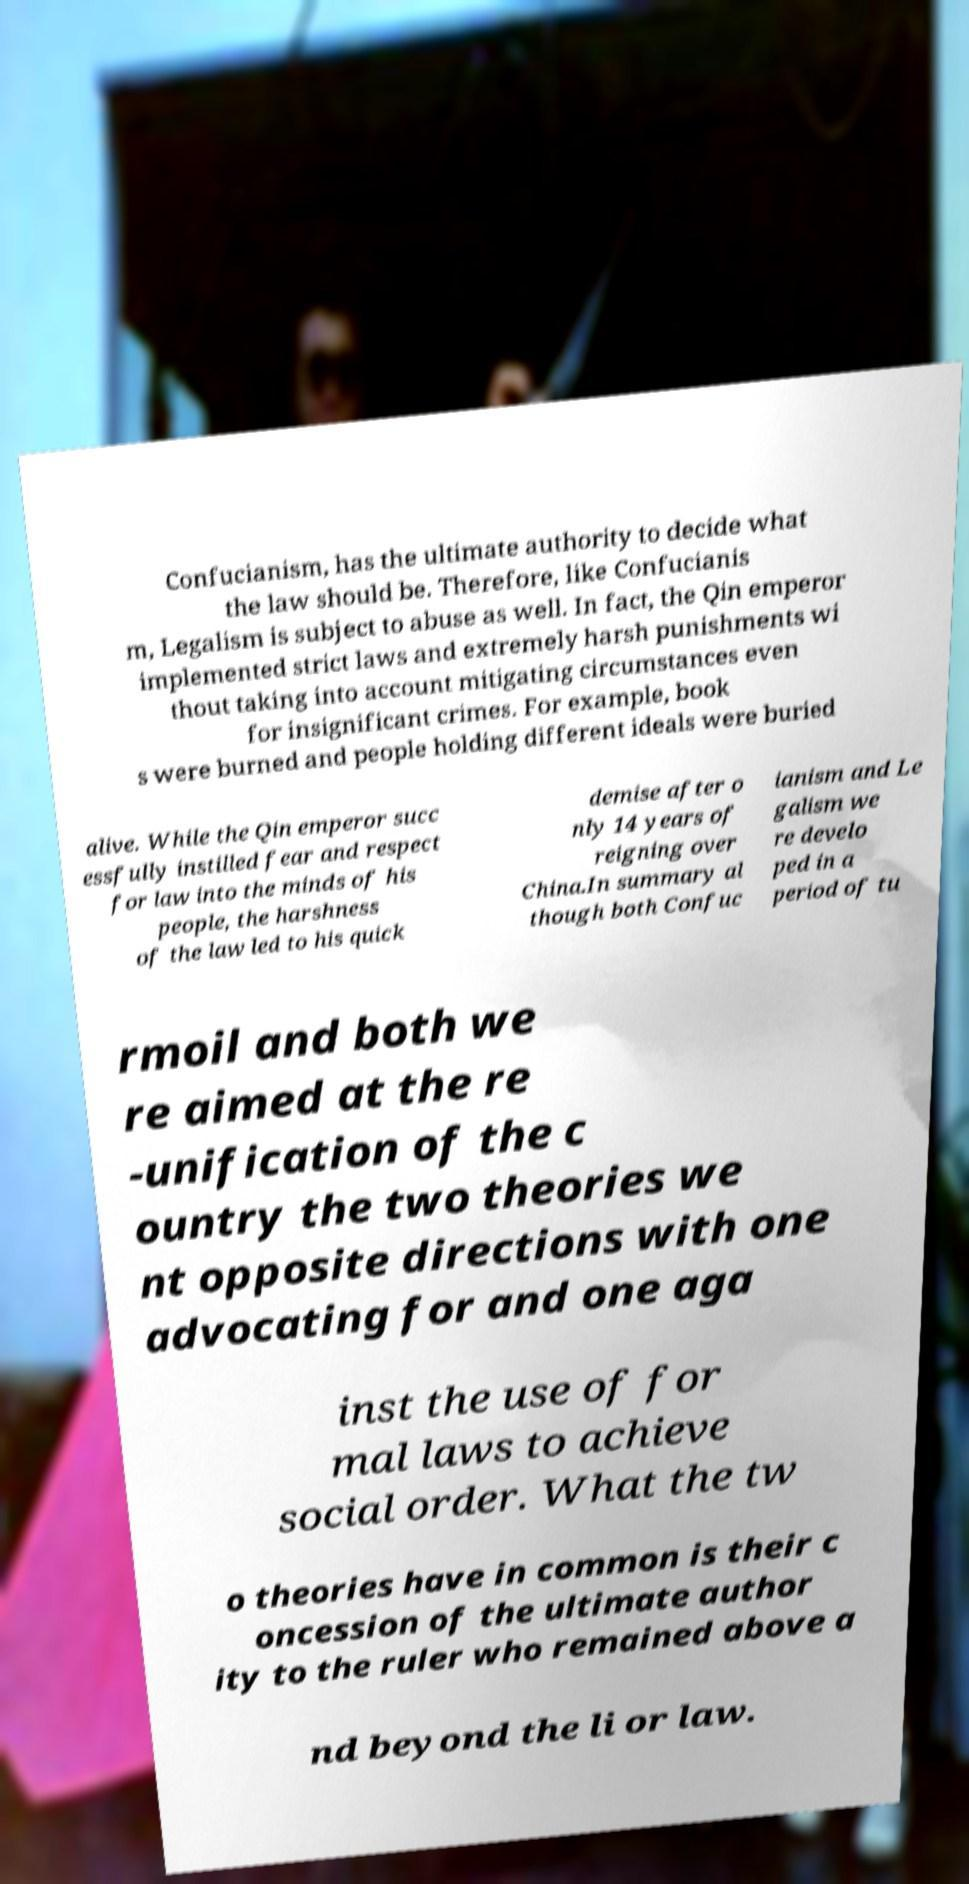For documentation purposes, I need the text within this image transcribed. Could you provide that? Confucianism, has the ultimate authority to decide what the law should be. Therefore, like Confucianis m, Legalism is subject to abuse as well. In fact, the Qin emperor implemented strict laws and extremely harsh punishments wi thout taking into account mitigating circumstances even for insignificant crimes. For example, book s were burned and people holding different ideals were buried alive. While the Qin emperor succ essfully instilled fear and respect for law into the minds of his people, the harshness of the law led to his quick demise after o nly 14 years of reigning over China.In summary al though both Confuc ianism and Le galism we re develo ped in a period of tu rmoil and both we re aimed at the re -unification of the c ountry the two theories we nt opposite directions with one advocating for and one aga inst the use of for mal laws to achieve social order. What the tw o theories have in common is their c oncession of the ultimate author ity to the ruler who remained above a nd beyond the li or law. 